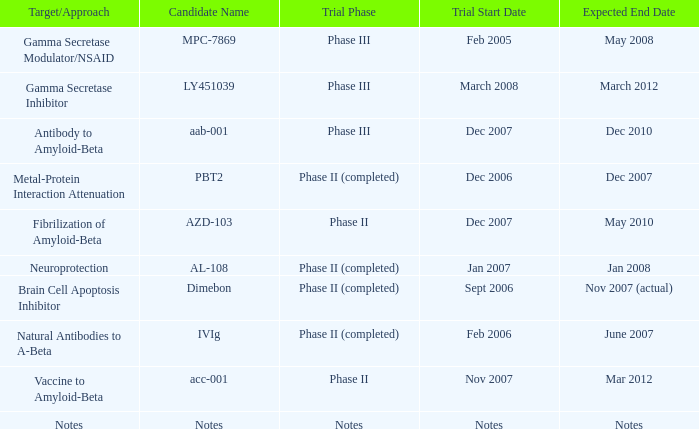What is Trial Phase, when Expected End Date is June 2007? Phase II (completed). 